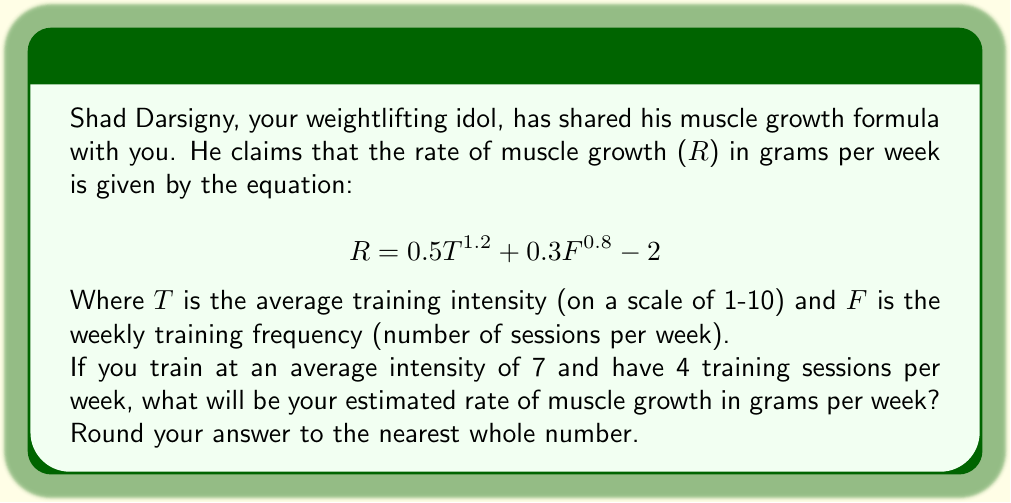Can you answer this question? Let's approach this step-by-step:

1) We are given the formula:
   $$ R = 0.5T^{1.2} + 0.3F^{0.8} - 2 $$

2) We know that:
   T = 7 (average training intensity)
   F = 4 (training sessions per week)

3) Let's substitute these values into the formula:
   $$ R = 0.5(7)^{1.2} + 0.3(4)^{0.8} - 2 $$

4) Now, let's calculate each term:
   
   First term: $0.5(7)^{1.2}$
   $7^{1.2} \approx 9.7425$
   $0.5 * 9.7425 \approx 4.8713$

   Second term: $0.3(4)^{0.8}$
   $4^{0.8} \approx 2.9907$
   $0.3 * 2.9907 \approx 0.8972$

5) Now our equation looks like:
   $$ R \approx 4.8713 + 0.8972 - 2 $$

6) Simplifying:
   $$ R \approx 3.7685 $$

7) Rounding to the nearest whole number:
   $$ R \approx 4 $$

Therefore, your estimated rate of muscle growth is approximately 4 grams per week.
Answer: 4 grams per week 